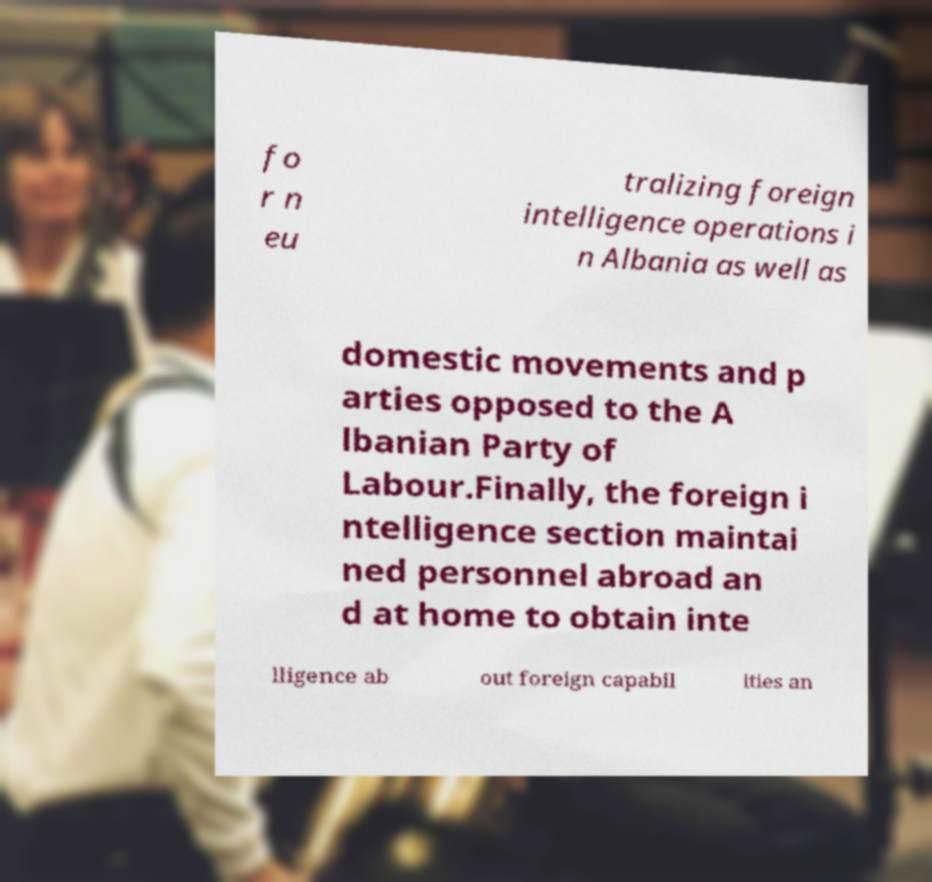There's text embedded in this image that I need extracted. Can you transcribe it verbatim? fo r n eu tralizing foreign intelligence operations i n Albania as well as domestic movements and p arties opposed to the A lbanian Party of Labour.Finally, the foreign i ntelligence section maintai ned personnel abroad an d at home to obtain inte lligence ab out foreign capabil ities an 